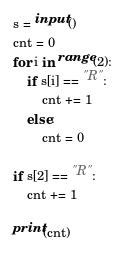Convert code to text. <code><loc_0><loc_0><loc_500><loc_500><_Python_>s = input()
cnt = 0
for i in range(2):
    if s[i] == "R":
        cnt += 1
    else:
        cnt = 0
        
if s[2] == "R":
    cnt += 1

print(cnt)</code> 